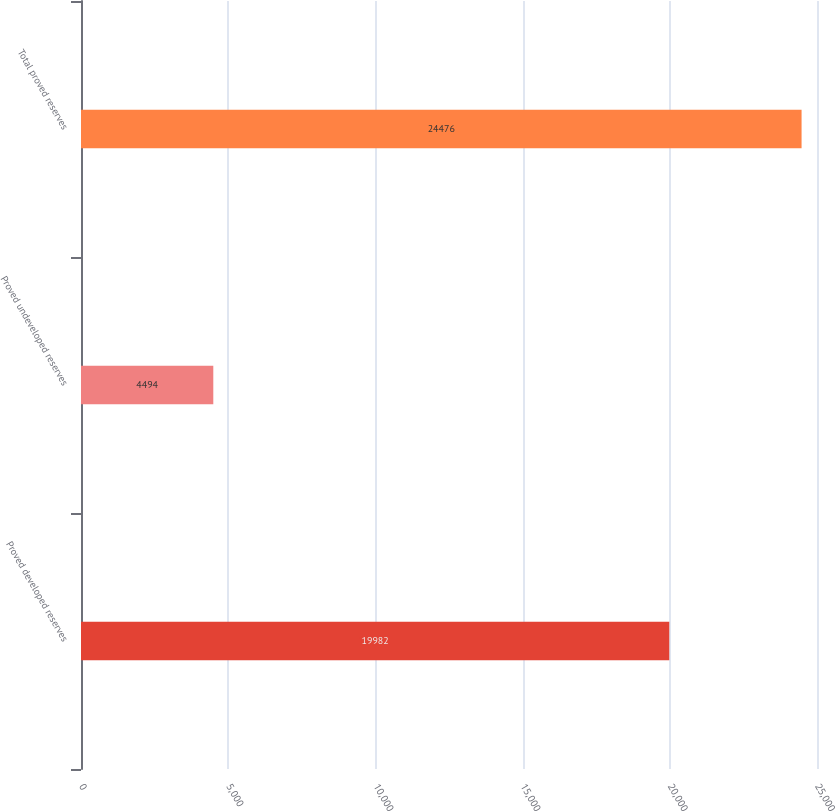Convert chart to OTSL. <chart><loc_0><loc_0><loc_500><loc_500><bar_chart><fcel>Proved developed reserves<fcel>Proved undeveloped reserves<fcel>Total proved reserves<nl><fcel>19982<fcel>4494<fcel>24476<nl></chart> 